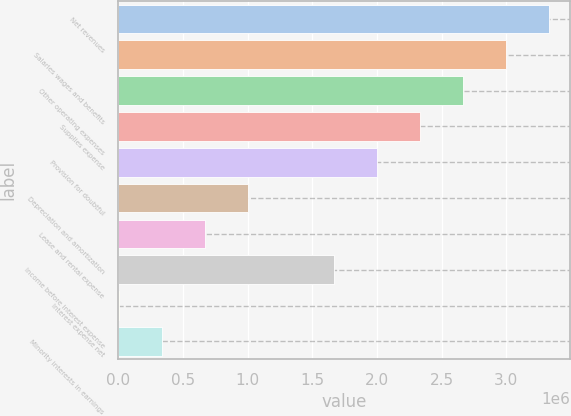Convert chart to OTSL. <chart><loc_0><loc_0><loc_500><loc_500><bar_chart><fcel>Net revenues<fcel>Salaries wages and benefits<fcel>Other operating expenses<fcel>Supplies expense<fcel>Provision for doubtful<fcel>Depreciation and amortization<fcel>Lease and rental expense<fcel>Income before interest expense<fcel>Interest expense net<fcel>Minority interests in earnings<nl><fcel>3.32973e+06<fcel>2.9971e+06<fcel>2.66447e+06<fcel>2.33185e+06<fcel>1.99922e+06<fcel>1.00134e+06<fcel>668712<fcel>1.66659e+06<fcel>3458<fcel>336085<nl></chart> 